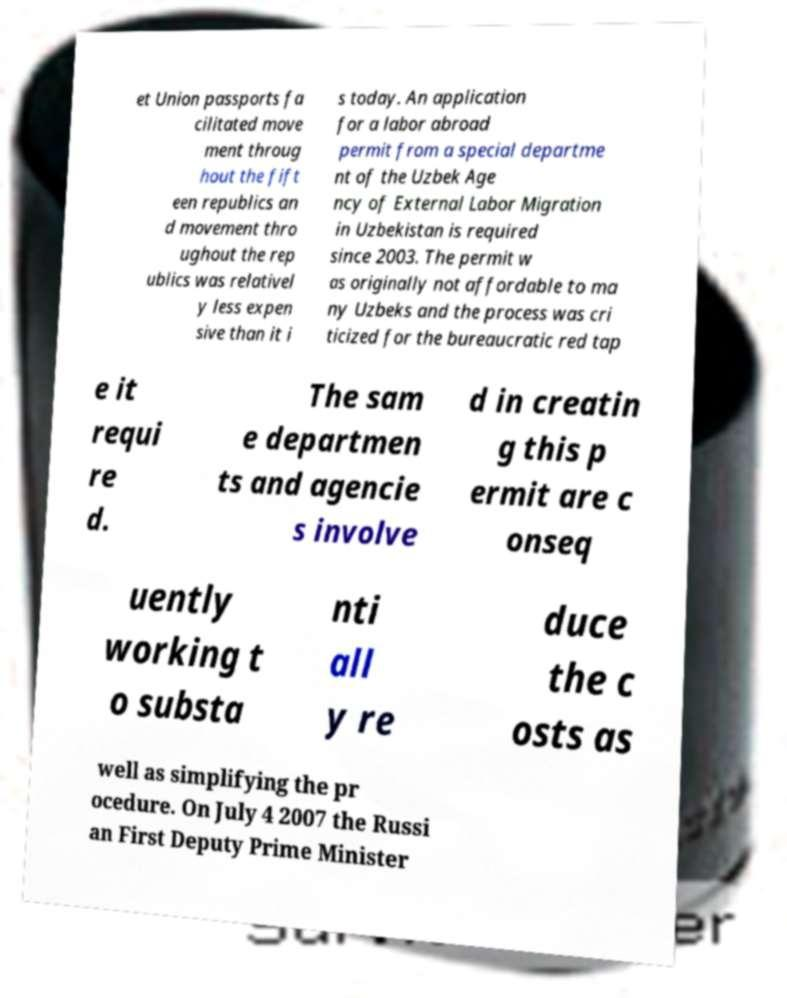What messages or text are displayed in this image? I need them in a readable, typed format. et Union passports fa cilitated move ment throug hout the fift een republics an d movement thro ughout the rep ublics was relativel y less expen sive than it i s today. An application for a labor abroad permit from a special departme nt of the Uzbek Age ncy of External Labor Migration in Uzbekistan is required since 2003. The permit w as originally not affordable to ma ny Uzbeks and the process was cri ticized for the bureaucratic red tap e it requi re d. The sam e departmen ts and agencie s involve d in creatin g this p ermit are c onseq uently working t o substa nti all y re duce the c osts as well as simplifying the pr ocedure. On July 4 2007 the Russi an First Deputy Prime Minister 